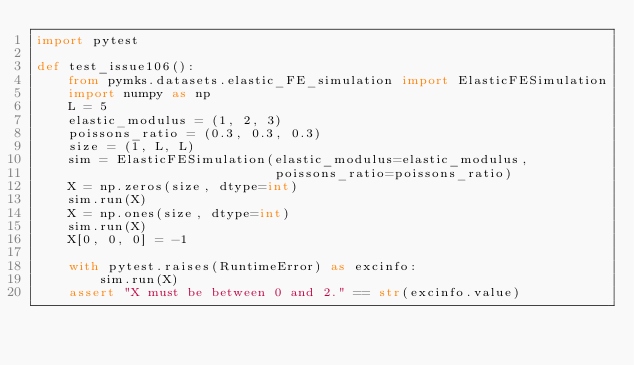Convert code to text. <code><loc_0><loc_0><loc_500><loc_500><_Python_>import pytest

def test_issue106():
    from pymks.datasets.elastic_FE_simulation import ElasticFESimulation
    import numpy as np
    L = 5
    elastic_modulus = (1, 2, 3)
    poissons_ratio = (0.3, 0.3, 0.3)
    size = (1, L, L)
    sim = ElasticFESimulation(elastic_modulus=elastic_modulus,
                              poissons_ratio=poissons_ratio)
    X = np.zeros(size, dtype=int)
    sim.run(X)
    X = np.ones(size, dtype=int)
    sim.run(X)
    X[0, 0, 0] = -1

    with pytest.raises(RuntimeError) as excinfo:
        sim.run(X)
    assert "X must be between 0 and 2." == str(excinfo.value)
</code> 